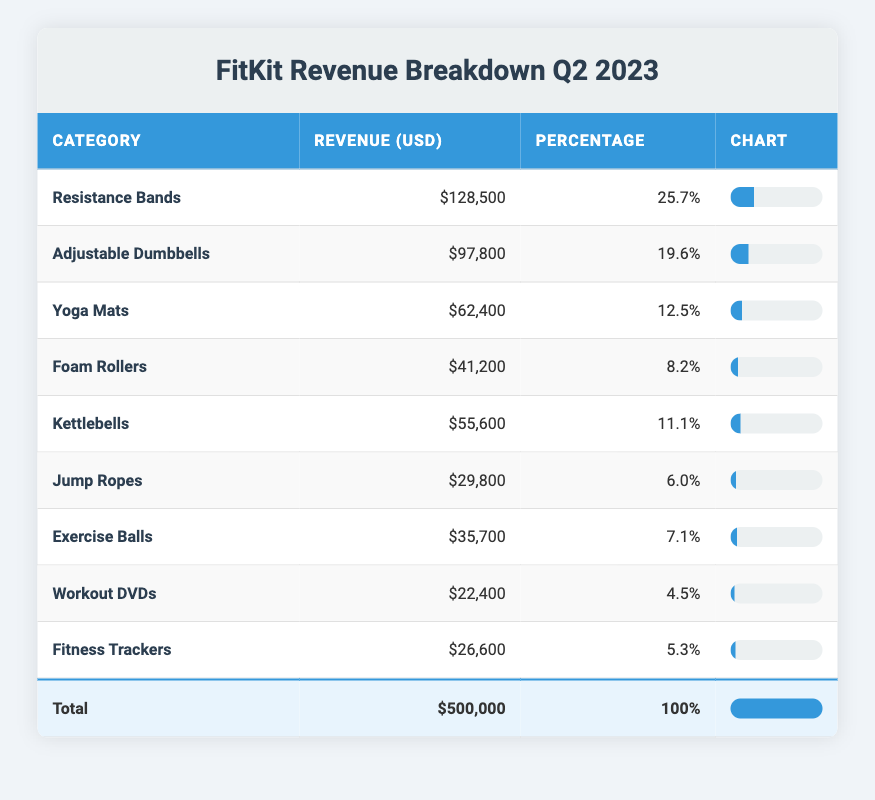What is the total revenue for Q2 2023? The total revenue is explicitly stated in the table as $500,000.
Answer: 500,000 Which product category generated the highest revenue? By reviewing the revenue values in the table, Resistance Bands has the highest revenue of $128,500.
Answer: Resistance Bands What percentage of the total revenue does Exercise Balls represent? The revenue for Exercise Balls is $35,700. To find the percentage, divide this by the total revenue ($500,000) and multiply by 100, yielding (35,700 / 500,000) * 100 = 7.14%.
Answer: 7.1% Are Workout DVDs among the top three highest-grossing product categories? Looking at the revenues listed, Workout DVDs has revenue of $22,400, which is lower than the revenues for Resistance Bands, Adjustable Dumbbells, and Yoga Mats, confirming that it is not in the top three.
Answer: No What is the combined revenue of Kettlebells and Jump Ropes? The revenue for Kettlebells is $55,600 and for Jump Ropes is $29,800. Summing these gives $55,600 + $29,800 = $85,400.
Answer: 85,400 Which category has the lowest revenue and what is that revenue? The category with the lowest revenue listed is Workout DVDs, with a revenue of $22,400.
Answer: Workout DVDs, 22,400 What fraction of the total revenue does Adjustable Dumbbells account for? The revenue for Adjustable Dumbbells is $97,800. The fraction of the total is found by dividing this by total revenue: 97,800 / 500,000 = 0.1956. This can be expressed as approximately 0.20 when rounded.
Answer: Approximately 0.20 Is the revenue from Yoga Mats greater than that from Foam Rollers? The revenue for Yoga Mats is $62,400, while Foam Rollers generate $41,200. Since $62,400 is greater than $41,200, the statement is true.
Answer: Yes What is the average percentage revenue contributed by the top three product categories? The top three categories' percentages are 25.7% (Resistance Bands), 19.6% (Adjustable Dumbbells), and 12.5% (Yoga Mats). To find the average, sum these percentages (25.7 + 19.6 + 12.5 = 57.8) and divide by 3, yielding an average of 57.8 / 3 = 19.27%.
Answer: 19.27% 